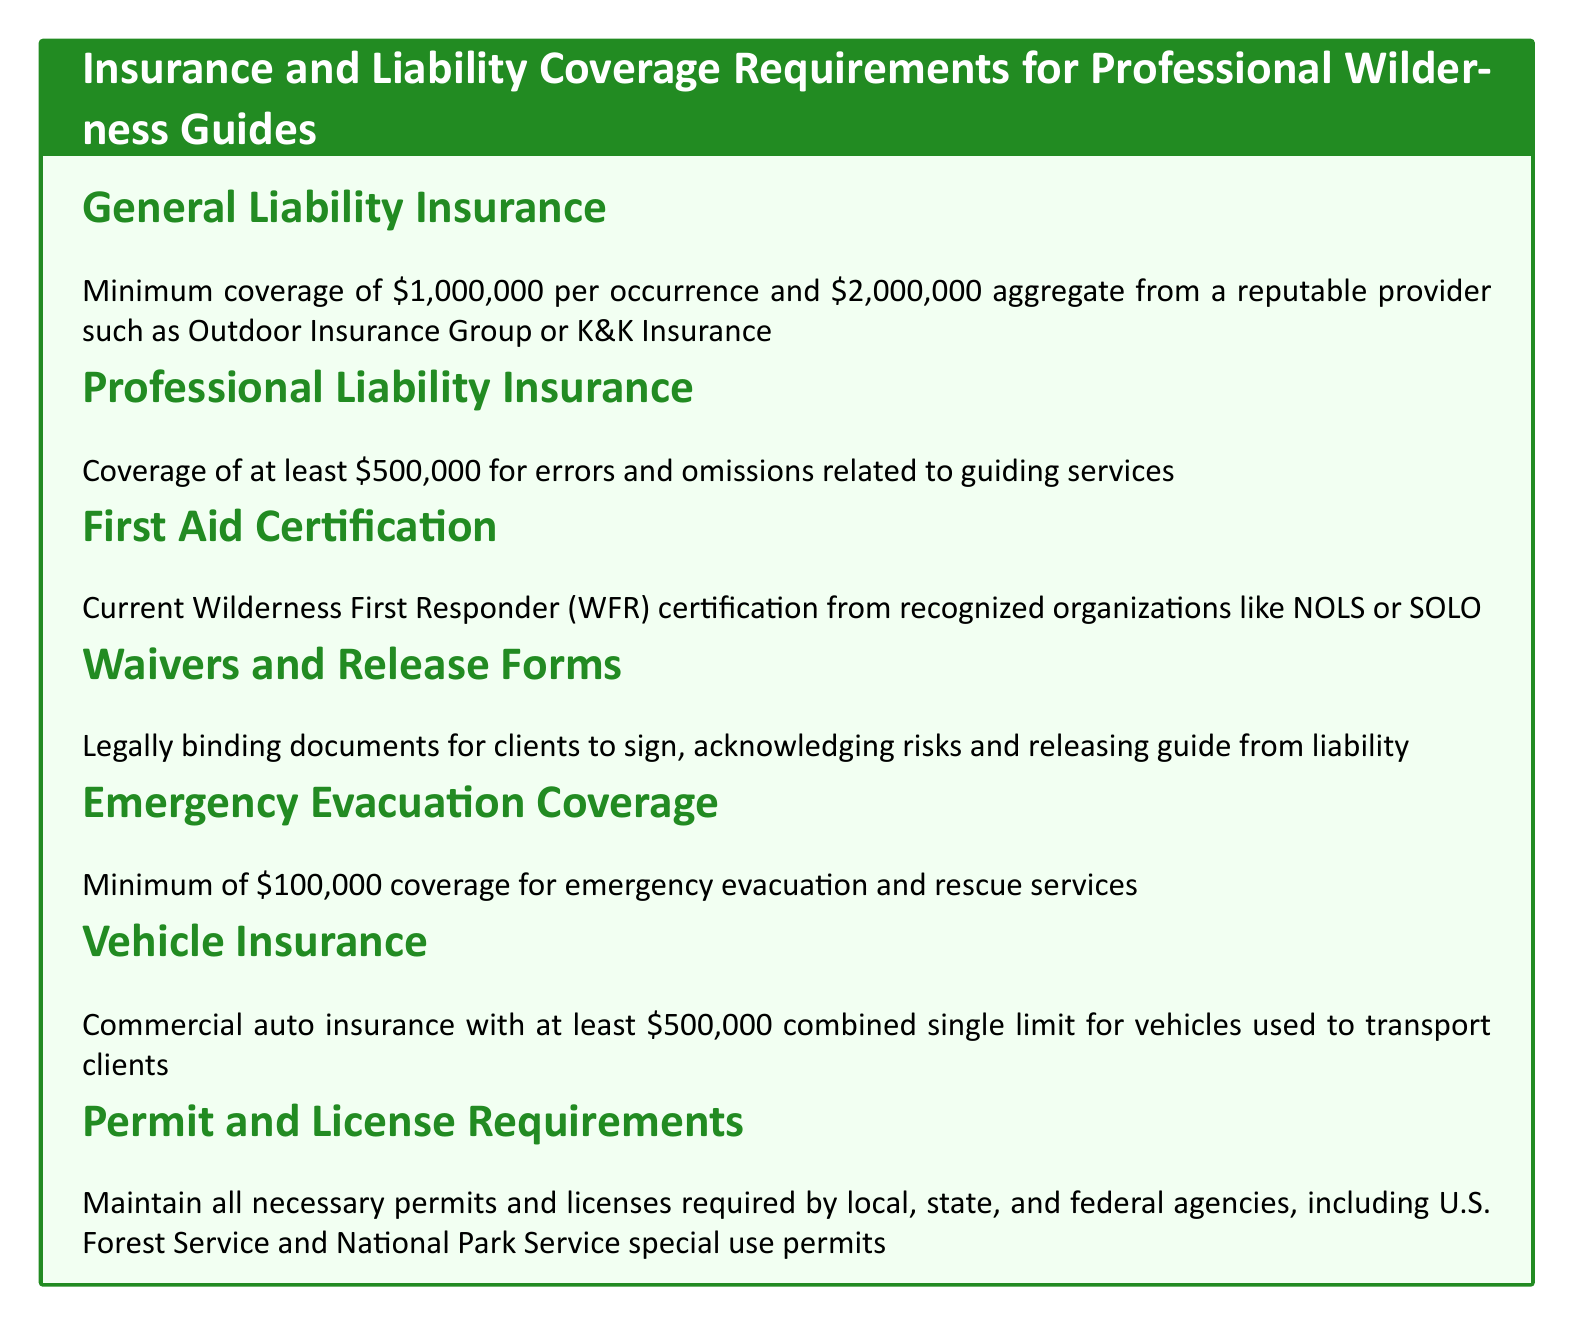What is the minimum coverage for General Liability Insurance? The document specifies that the minimum coverage for General Liability Insurance is \$1,000,000 per occurrence and \$2,000,000 aggregate.
Answer: \$1,000,000 per occurrence and \$2,000,000 aggregate What is the required coverage for Professional Liability Insurance? According to the document, the required coverage for Professional Liability Insurance is at least \$500,000.
Answer: \$500,000 What certification is required for First Aid? The document states that a current Wilderness First Responder (WFR) certification is required.
Answer: Wilderness First Responder (WFR) What is the minimum coverage for Emergency Evacuation? The document indicates a minimum of \$100,000 coverage for emergency evacuation.
Answer: \$100,000 What type of insurance is required for vehicles? The document specifies that commercial auto insurance is required for vehicles used to transport clients.
Answer: Commercial auto insurance Why is a waiver needed for clients? The document states that waivers and release forms are needed for clients to acknowledge risks and release the guide from liability, indicating legal protection.
Answer: Legal protection What is the permit requirement mentioned in the document? The document requires maintaining all necessary permits and licenses from local, state, and federal agencies.
Answer: Necessary permits and licenses What is the aggregate coverage amount for General Liability Insurance? The document specifies that the aggregate coverage amount for General Liability Insurance is \$2,000,000.
Answer: \$2,000,000 What organization is mentioned for Wilderness First Responder certification? The document mentions organizations like NOLS or SOLO for Wilderness First Responder certification.
Answer: NOLS or SOLO 